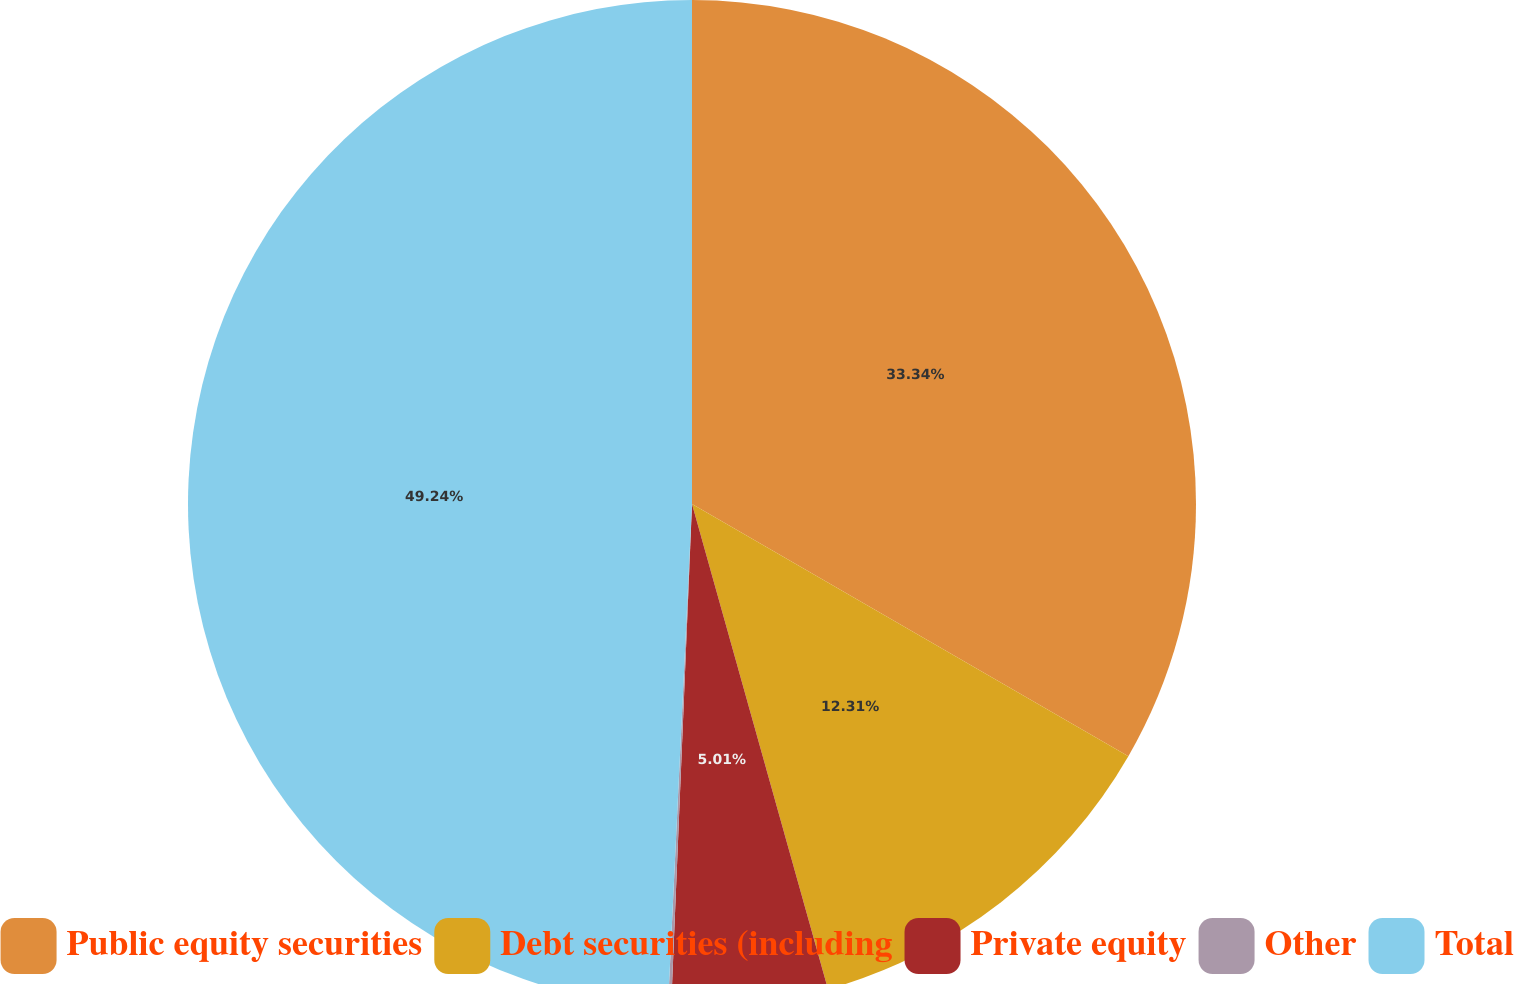Convert chart. <chart><loc_0><loc_0><loc_500><loc_500><pie_chart><fcel>Public equity securities<fcel>Debt securities (including<fcel>Private equity<fcel>Other<fcel>Total<nl><fcel>33.34%<fcel>12.31%<fcel>5.01%<fcel>0.1%<fcel>49.24%<nl></chart> 